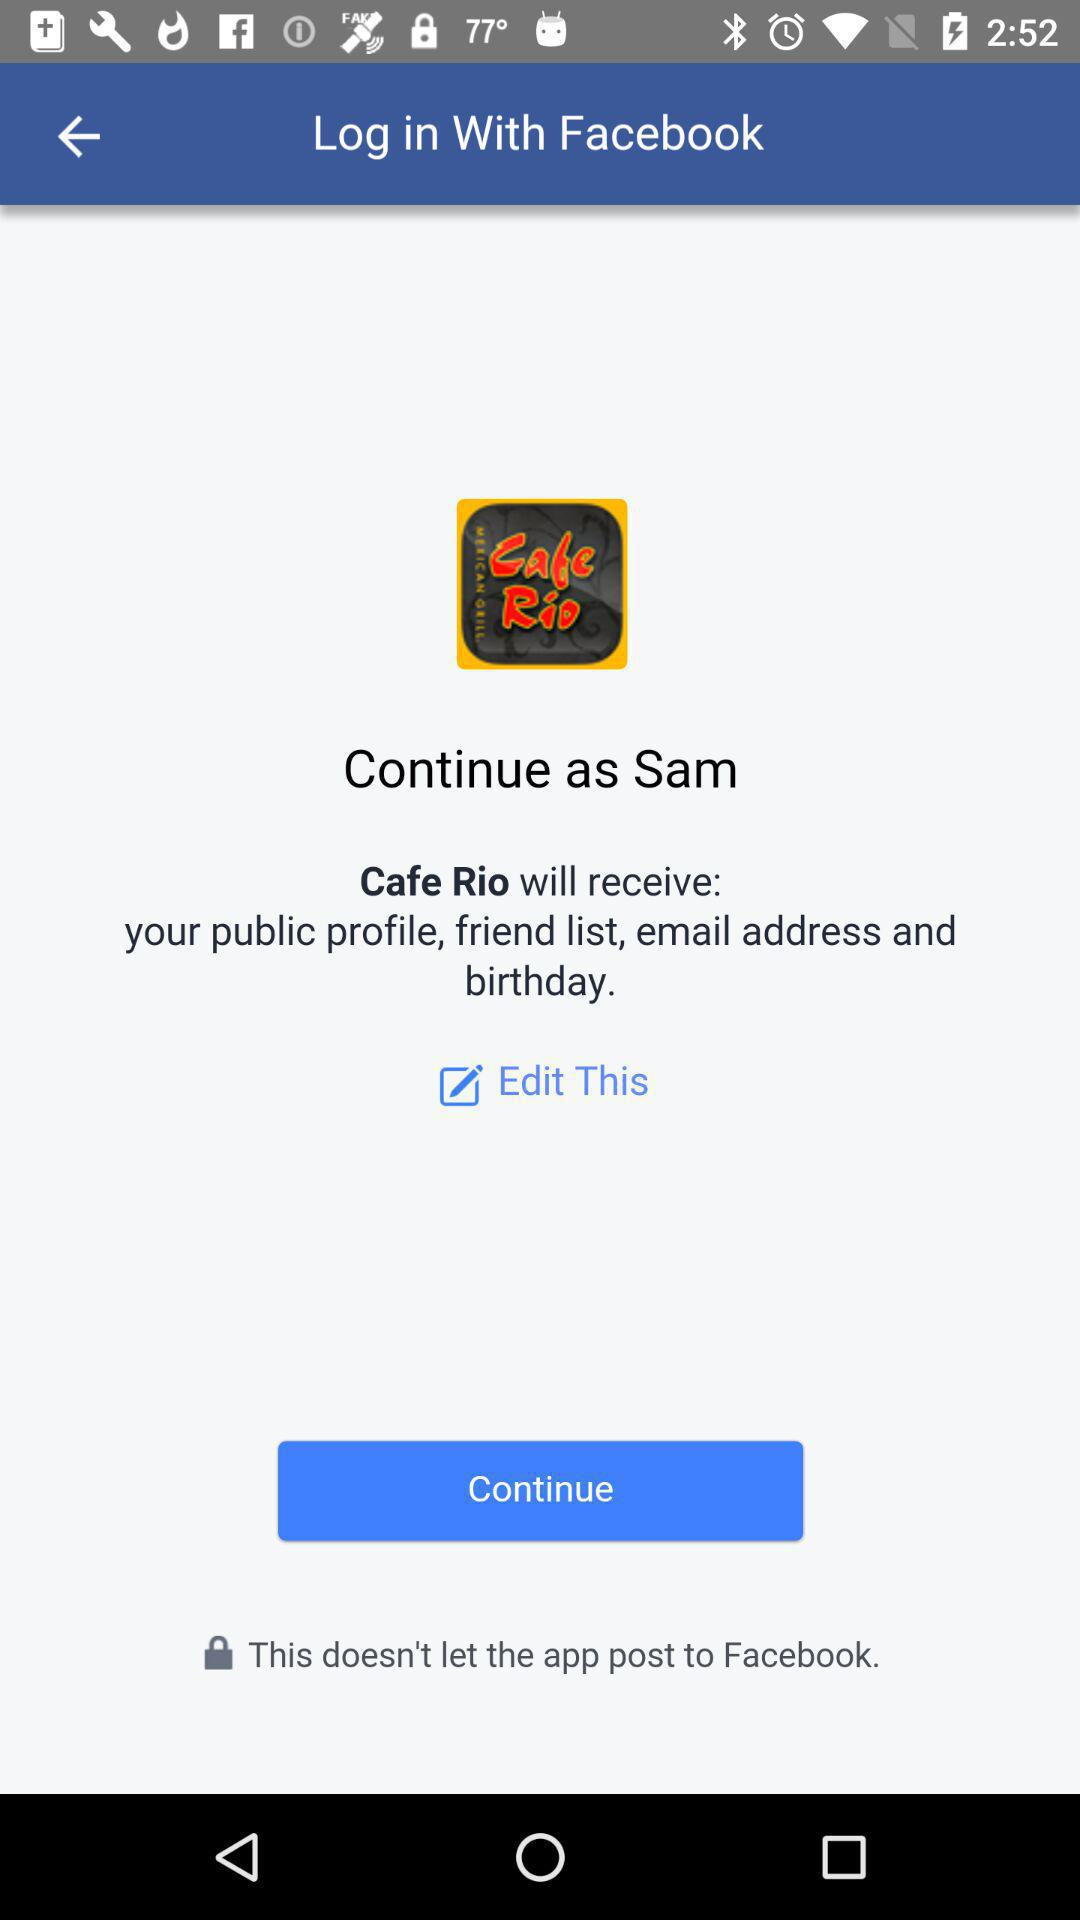What application is asking for permission? The application asking for permission is "Cafe Rio". 